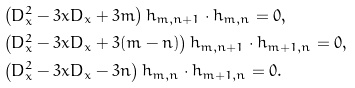<formula> <loc_0><loc_0><loc_500><loc_500>& \left ( D _ { x } ^ { 2 } - 3 x D _ { x } + 3 m \right ) h _ { m , n + 1 } \cdot h _ { m , n } = 0 , \\ & \left ( D _ { x } ^ { 2 } - 3 x D _ { x } + 3 ( m - n ) \right ) h _ { m , n + 1 } \cdot h _ { m + 1 , n } = 0 , \\ & \left ( D _ { x } ^ { 2 } - 3 x D _ { x } - 3 n \right ) h _ { m , n } \cdot h _ { m + 1 , n } = 0 .</formula> 